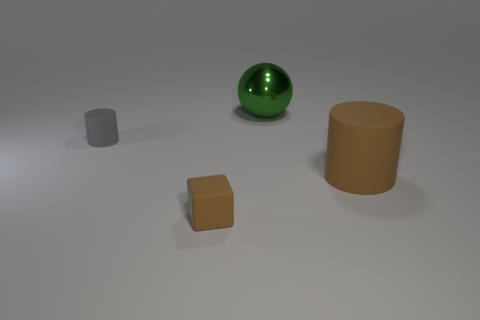Add 2 blue matte objects. How many objects exist? 6 Subtract all blocks. How many objects are left? 3 Subtract 1 spheres. How many spheres are left? 0 Subtract all purple blocks. Subtract all brown spheres. How many blocks are left? 1 Subtract all cyan spheres. How many green cylinders are left? 0 Subtract all cyan metallic cubes. Subtract all small objects. How many objects are left? 2 Add 2 metal balls. How many metal balls are left? 3 Add 2 blue rubber cylinders. How many blue rubber cylinders exist? 2 Subtract 0 cyan cubes. How many objects are left? 4 